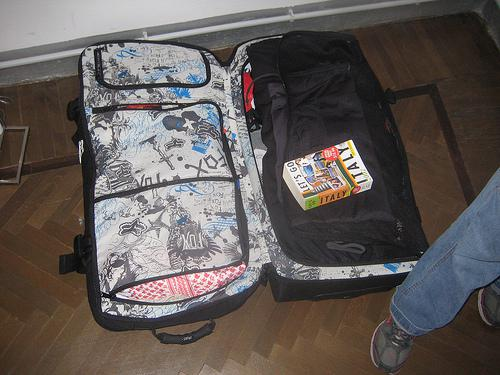Question: what is on the bag?
Choices:
A. A magazine.
B. An electronic book reader.
C. A stuffed animal.
D. A book.
Answer with the letter. Answer: D Question: what is the color of the person's shoes?
Choices:
A. Black.
B. Gray.
C. Brown.
D. Blue.
Answer with the letter. Answer: B Question: who is standing beside the bag?
Choices:
A. A person.
B. A skycap.
C. A flight attendant.
D. A child.
Answer with the letter. Answer: A Question: why the bag is packed?
Choices:
A. To go on a trip.
B. To take to the hospital when baby is born.
C. To keep things out of the way.
D. To leave.
Answer with the letter. Answer: D 